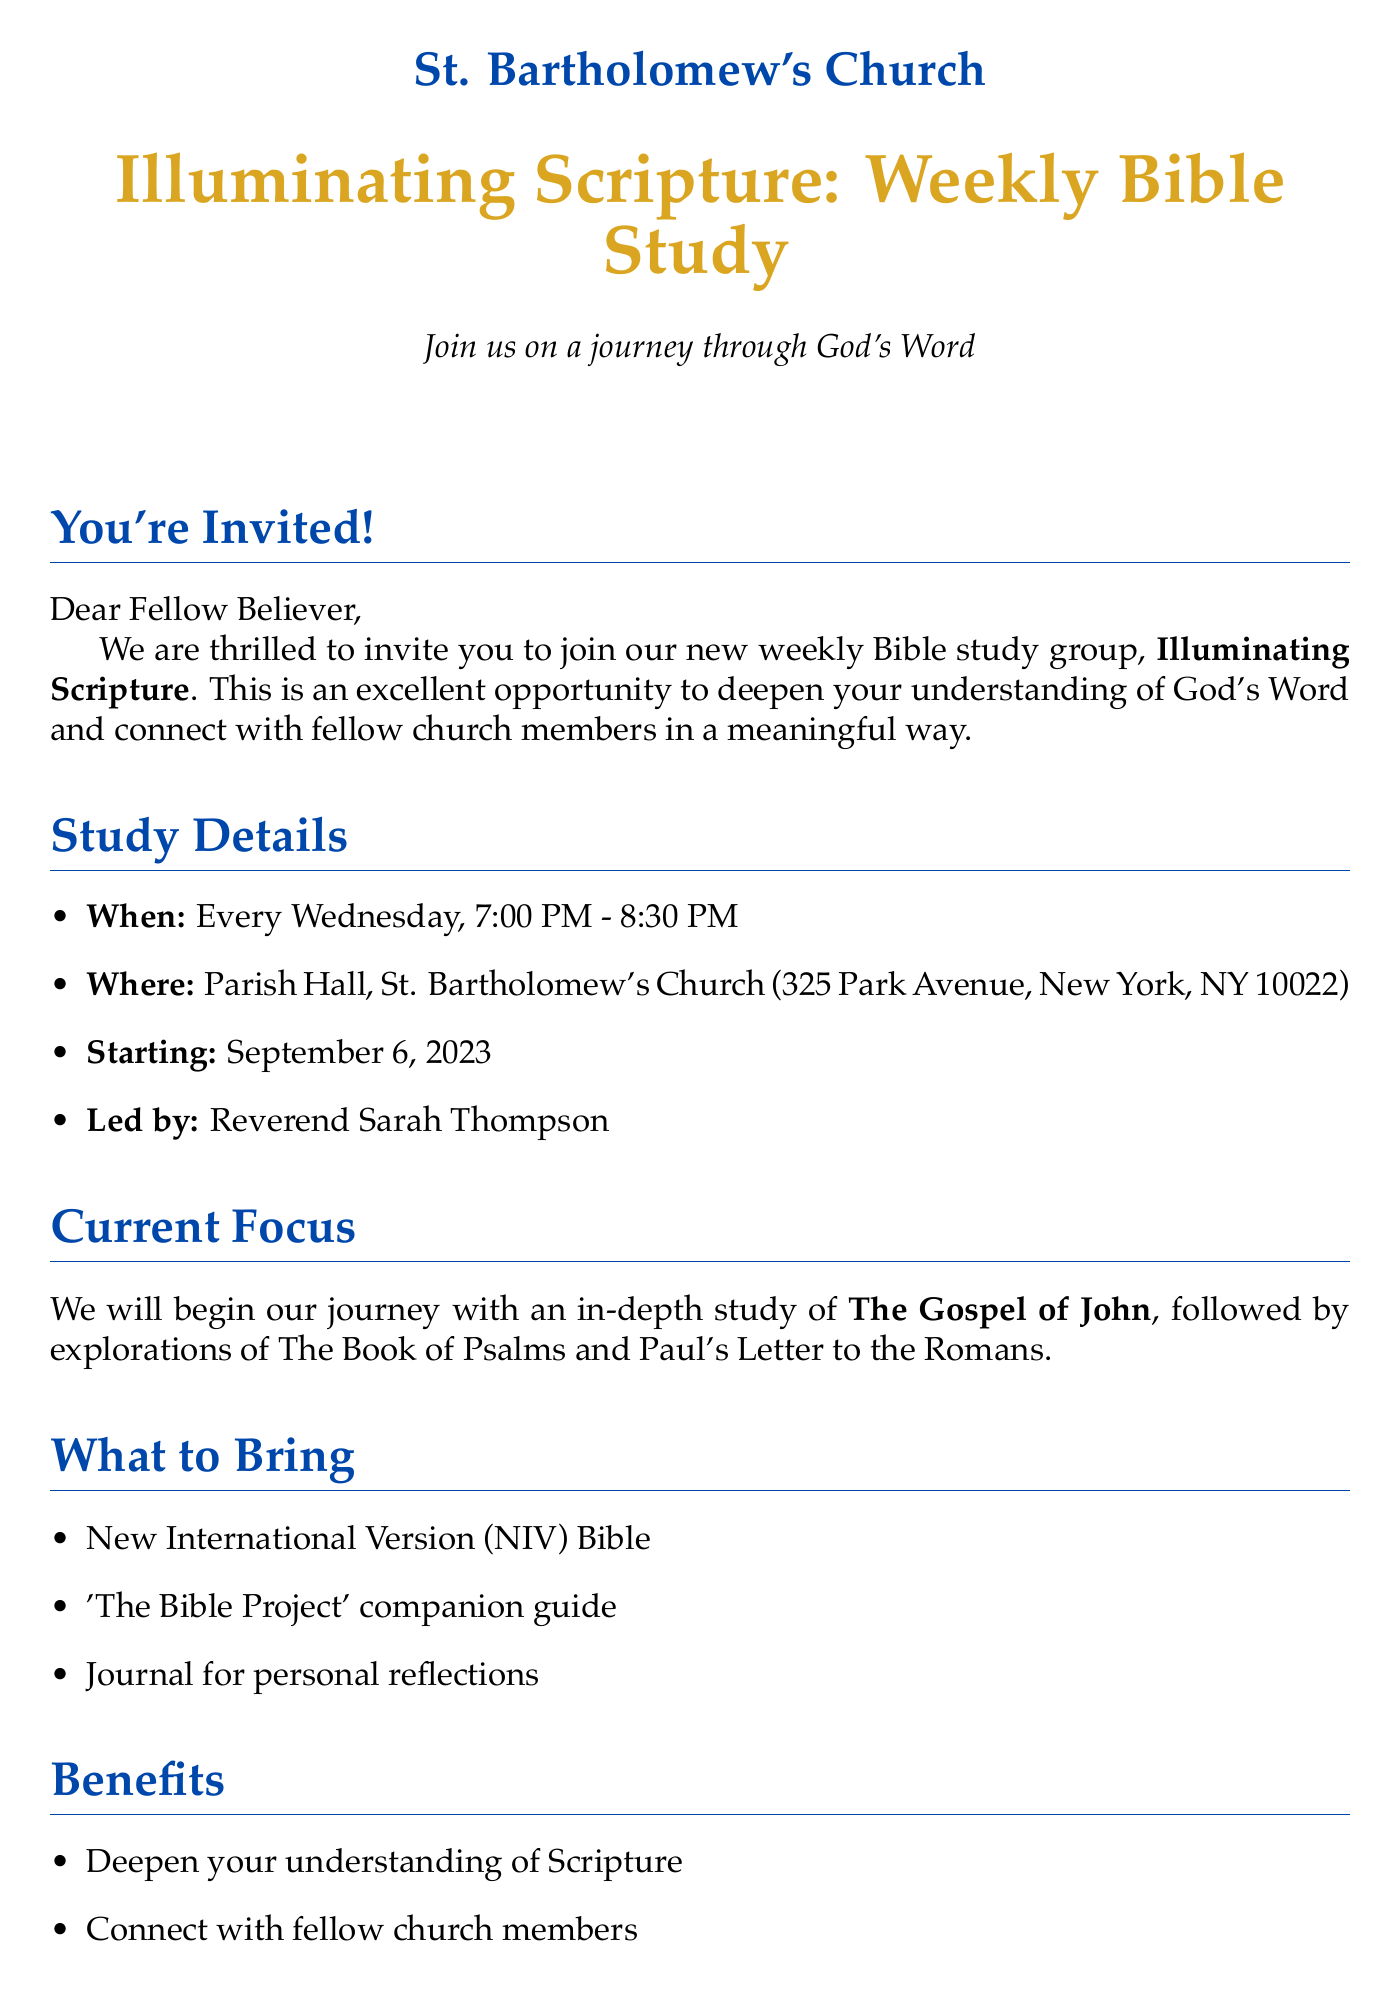what is the name of the Bible study group? The name of the Bible study group is specified as "Illuminating Scripture: Weekly Bible Study."
Answer: Illuminating Scripture: Weekly Bible Study who will lead the Bible study sessions? The document mentions that the Bible study will be led by Reverend Sarah Thompson.
Answer: Reverend Sarah Thompson when does the Bible study start? The starting date of the Bible study is clearly indicated in the document as September 6, 2023.
Answer: September 6, 2023 where is the Bible study held? The location for the Bible study sessions is provided as Parish Hall, St. Bartholomew's Church.
Answer: Parish Hall, St. Bartholomew's Church what study materials are needed for the Bible study? The document lists specific materials needed, including the New International Version (NIV) Bible, 'The Bible Project' companion guide, and a journal for personal reflections.
Answer: New International Version (NIV) Bible, 'The Bible Project' companion guide, Journal for personal reflections how often do the Bible study meetings occur? The frequency of the meetings is stated as "Every Wednesday."
Answer: Every Wednesday what type of refreshment is provided during the study? The document mentions that light refreshments and coffee will be provided.
Answer: Light refreshments and coffee is childcare available? The document clearly states that free childcare is available for children under 10.
Answer: Free childcare available for children under 10 how can one register for the Bible study? Instructions for registration are given in the document as signing up at the welcome desk or emailing office@stbarts.org.
Answer: Sign up at the welcome desk or email office@stbarts.org 